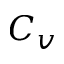<formula> <loc_0><loc_0><loc_500><loc_500>C _ { v }</formula> 